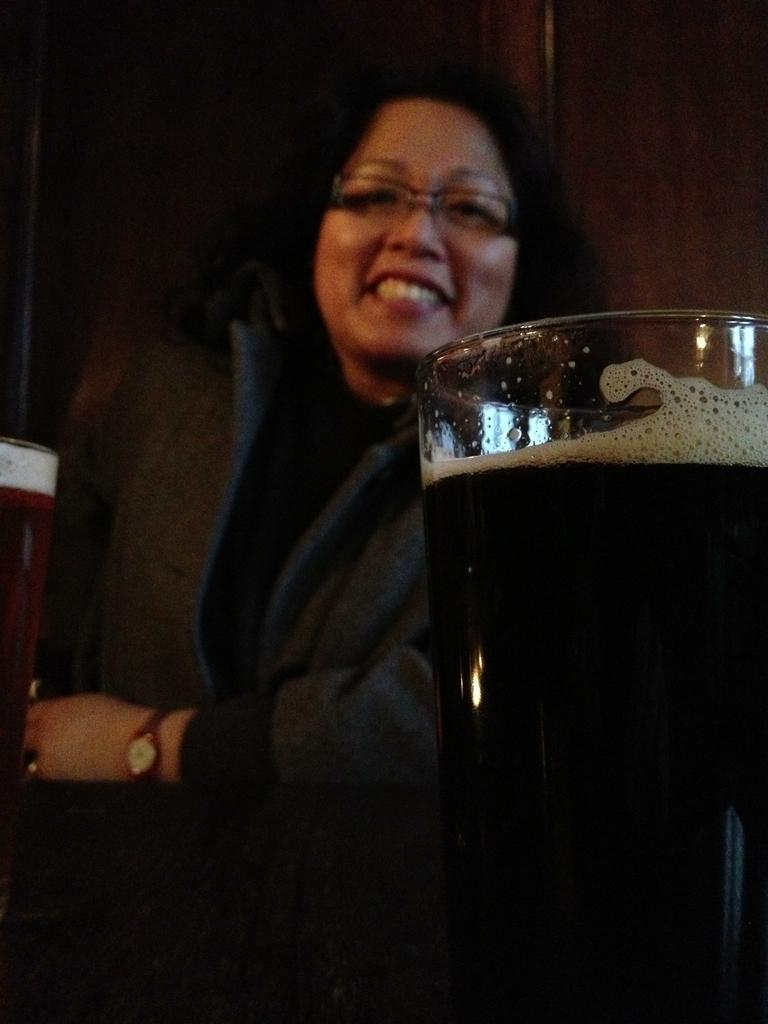What objects are on the table in the image? There are glasses with liquids on the table in the image. What is the woman in the image doing? The woman is smiling in the image. What is the color of the background in the image? The background of the image is dark. What is the name of the group that is performing in the image? There is no group or performance present in the image; it features glasses with liquids on a table and a smiling woman. What type of wool can be seen in the image? There is no wool present in the image. 